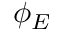<formula> <loc_0><loc_0><loc_500><loc_500>\phi _ { E }</formula> 